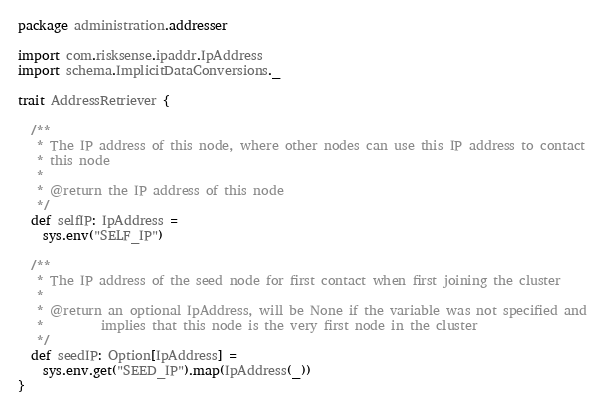<code> <loc_0><loc_0><loc_500><loc_500><_Scala_>package administration.addresser

import com.risksense.ipaddr.IpAddress
import schema.ImplicitDataConversions._

trait AddressRetriever {

  /**
   * The IP address of this node, where other nodes can use this IP address to contact
   * this node
   *
   * @return the IP address of this node
   */
  def selfIP: IpAddress =
    sys.env("SELF_IP")

  /**
   * The IP address of the seed node for first contact when first joining the cluster
   *
   * @return an optional IpAddress, will be None if the variable was not specified and
   *         implies that this node is the very first node in the cluster
   */
  def seedIP: Option[IpAddress] =
    sys.env.get("SEED_IP").map(IpAddress(_))
}
</code> 